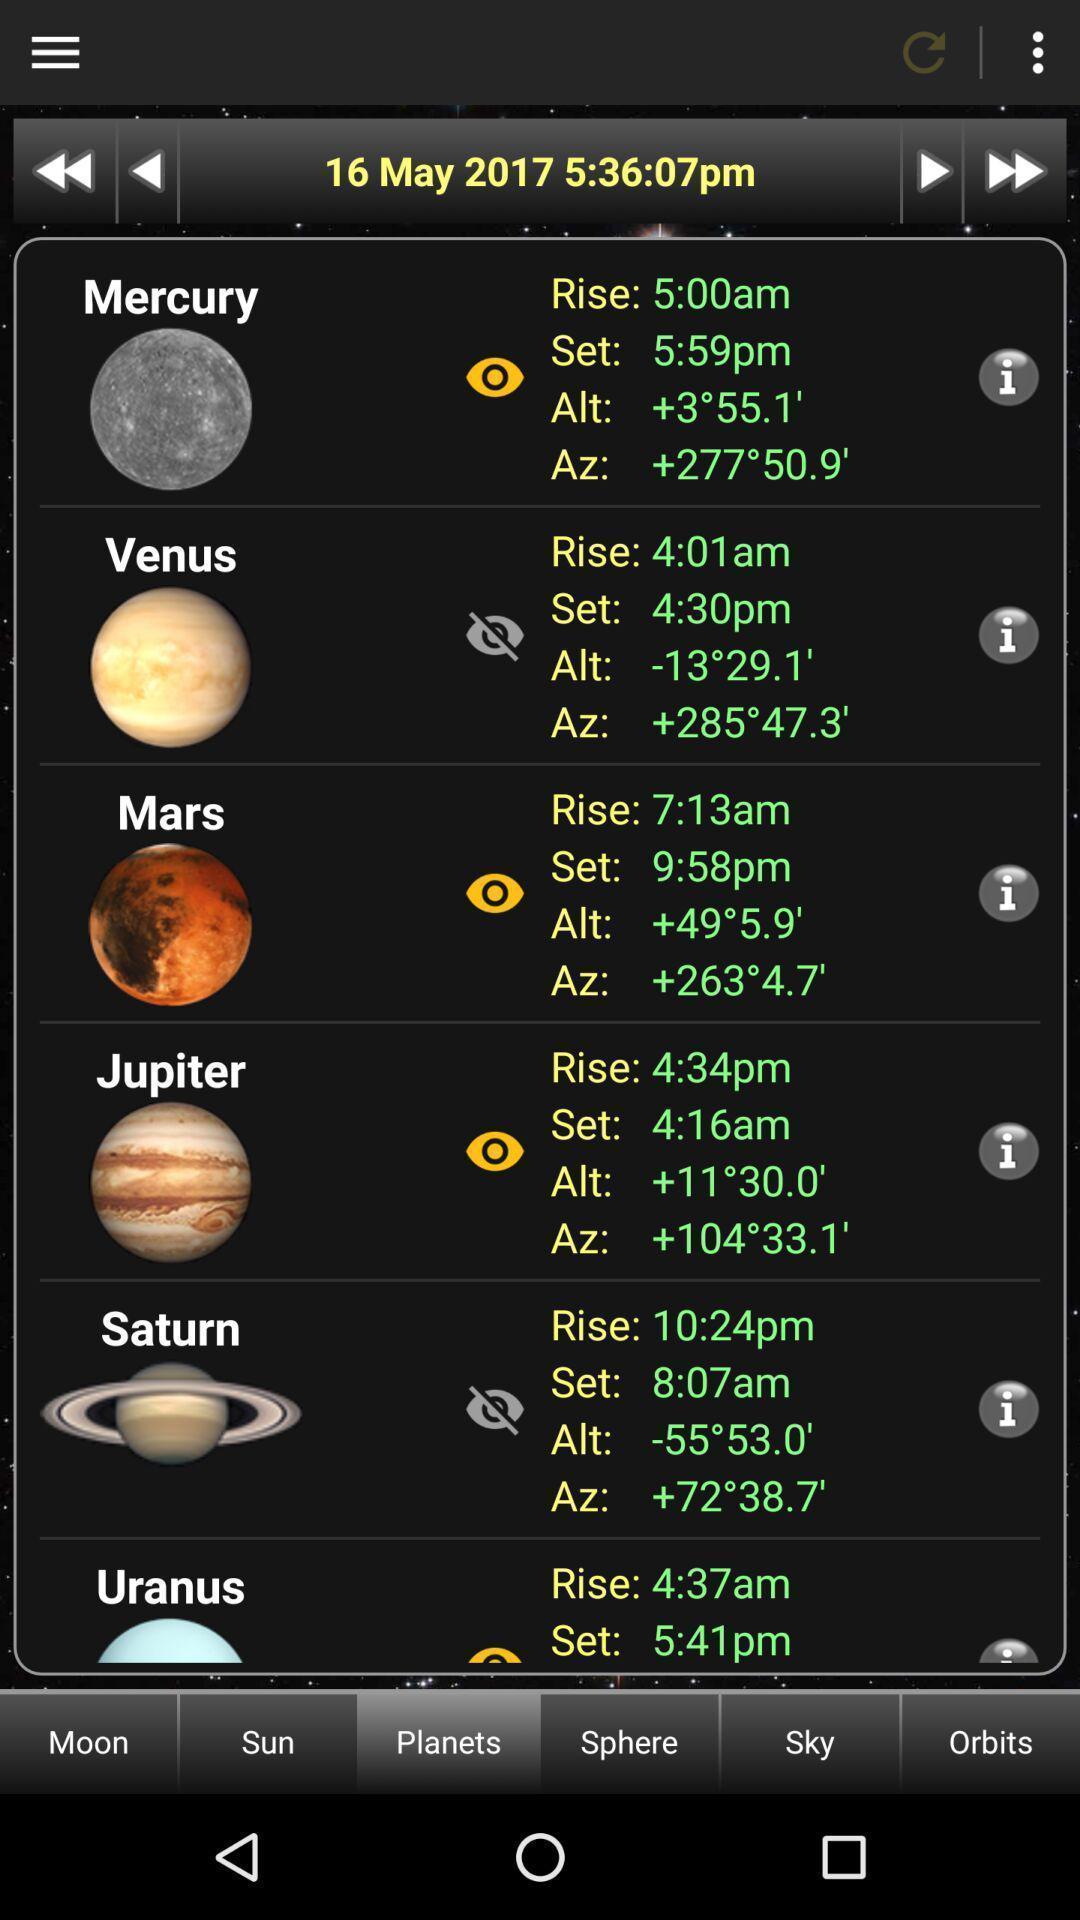Describe the content in this image. Window displaying information about planets. 